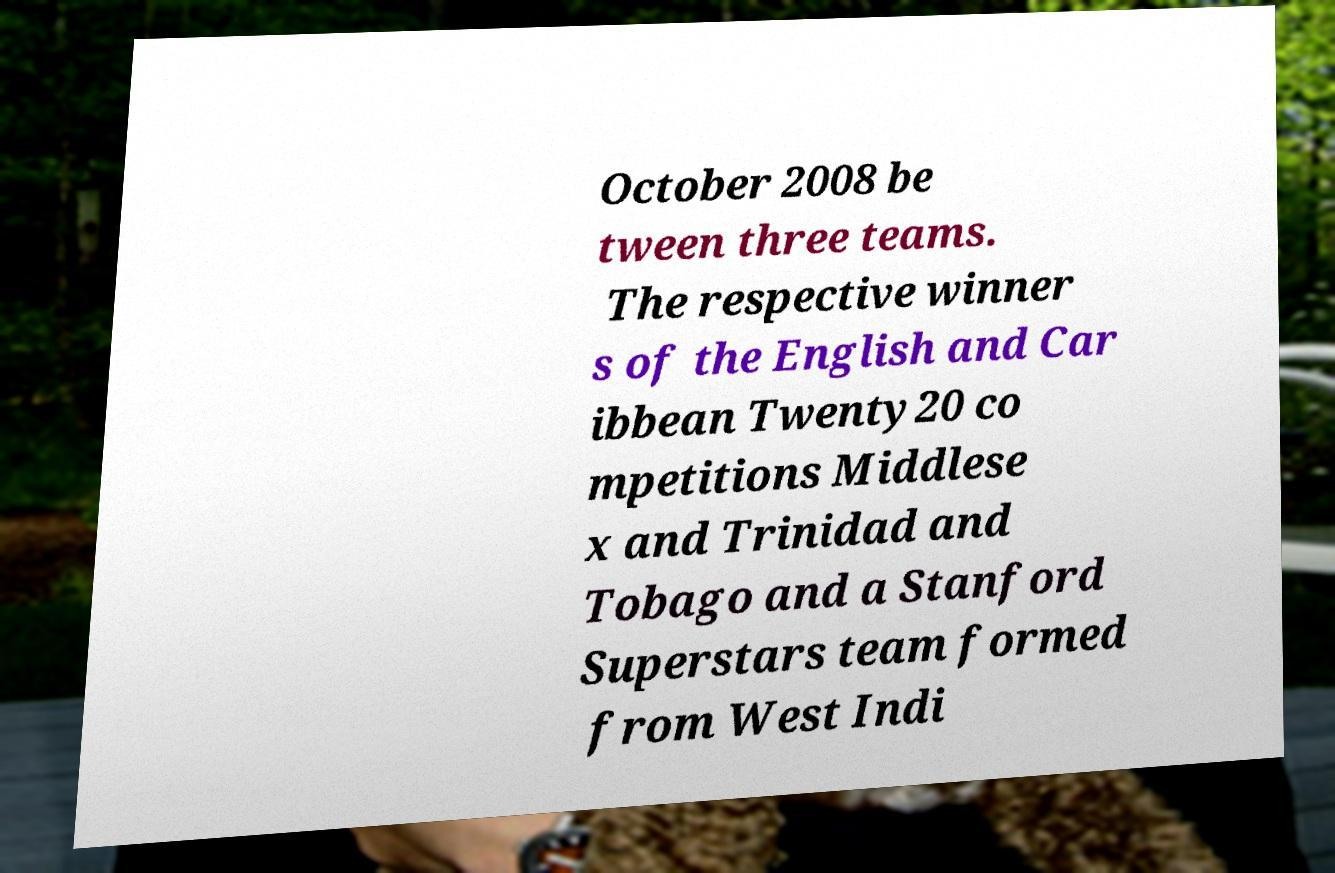Please identify and transcribe the text found in this image. October 2008 be tween three teams. The respective winner s of the English and Car ibbean Twenty20 co mpetitions Middlese x and Trinidad and Tobago and a Stanford Superstars team formed from West Indi 